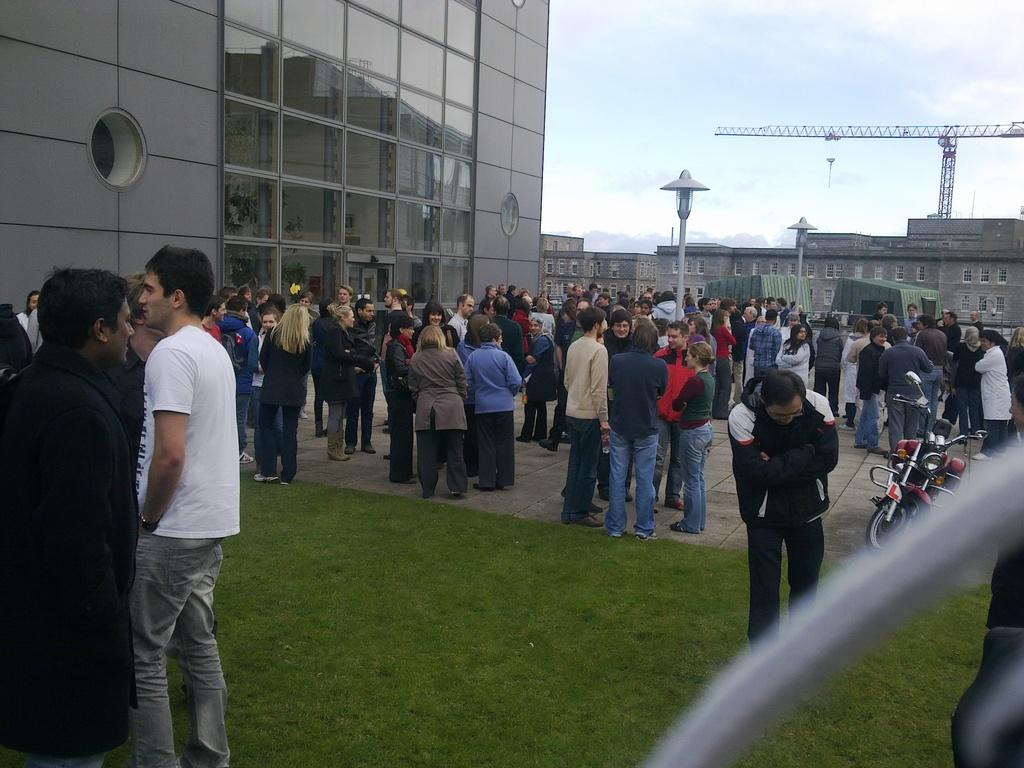Who or what can be seen in the image? There are people in the image. What object is visible in the image that can be used for transportation? There is a bike in the image. What type of terrain is present in the image? There is grass in the image. What can be seen in the distance in the image? There are buildings, lights on poles, and a crane in the background of the image. What is visible in the sky in the image? The sky is visible in the background of the image, and there are clouds in the sky. Where is the rake being used in the image? There is no rake present in the image. What type of fruit is being stored in the basket in the image? There is no basket or fruit present in the image. 